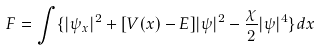Convert formula to latex. <formula><loc_0><loc_0><loc_500><loc_500>F = \int \{ | \psi _ { x } | ^ { 2 } + [ V ( x ) - E ] | \psi | ^ { 2 } - \frac { \chi } { 2 } | \psi | ^ { 4 } \} d x</formula> 